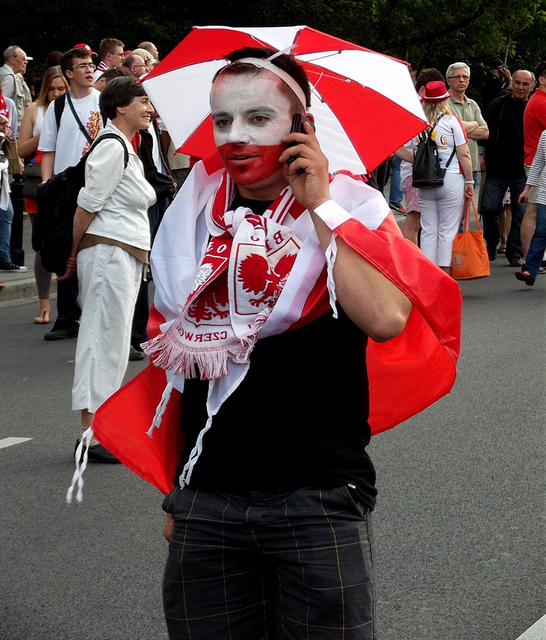Identify the text contained in this image. B CSERW a 